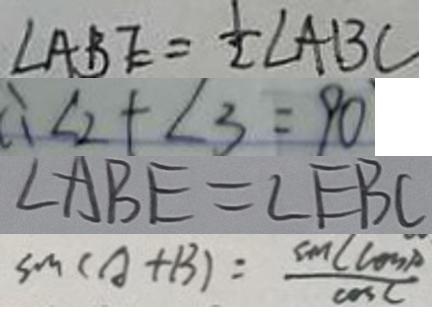Convert formula to latex. <formula><loc_0><loc_0><loc_500><loc_500>\angle A B E = \frac { 1 } { 2 } \angle A B C 
 \therefore \angle 2 + \angle 3 = 9 0 
 \angle A B E = \angle E B C 
 \sin ( A + B ) = \frac { \sin C \cos p } { \cos C }</formula> 